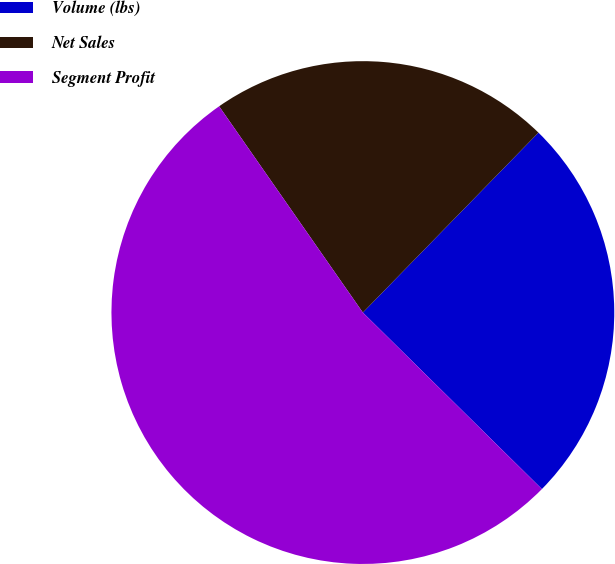Convert chart. <chart><loc_0><loc_0><loc_500><loc_500><pie_chart><fcel>Volume (lbs)<fcel>Net Sales<fcel>Segment Profit<nl><fcel>25.08%<fcel>21.99%<fcel>52.92%<nl></chart> 